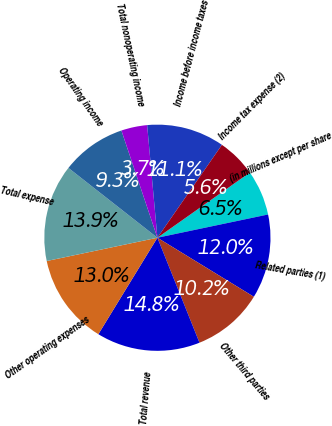<chart> <loc_0><loc_0><loc_500><loc_500><pie_chart><fcel>(in millions except per share<fcel>Related parties (1)<fcel>Other third parties<fcel>Total revenue<fcel>Other operating expenses<fcel>Total expense<fcel>Operating income<fcel>Total nonoperating income<fcel>Income before income taxes<fcel>Income tax expense (2)<nl><fcel>6.48%<fcel>12.04%<fcel>10.19%<fcel>14.81%<fcel>12.96%<fcel>13.89%<fcel>9.26%<fcel>3.71%<fcel>11.11%<fcel>5.56%<nl></chart> 